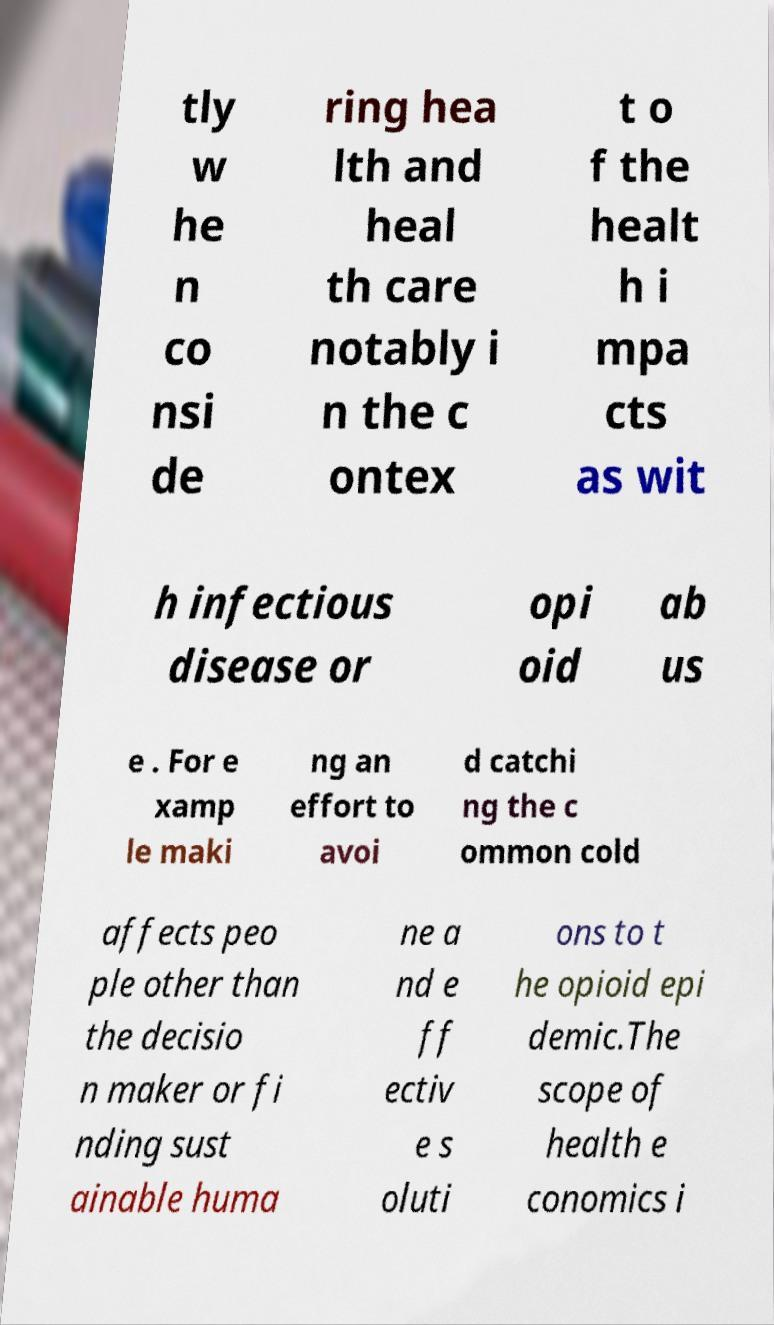Could you extract and type out the text from this image? tly w he n co nsi de ring hea lth and heal th care notably i n the c ontex t o f the healt h i mpa cts as wit h infectious disease or opi oid ab us e . For e xamp le maki ng an effort to avoi d catchi ng the c ommon cold affects peo ple other than the decisio n maker or fi nding sust ainable huma ne a nd e ff ectiv e s oluti ons to t he opioid epi demic.The scope of health e conomics i 